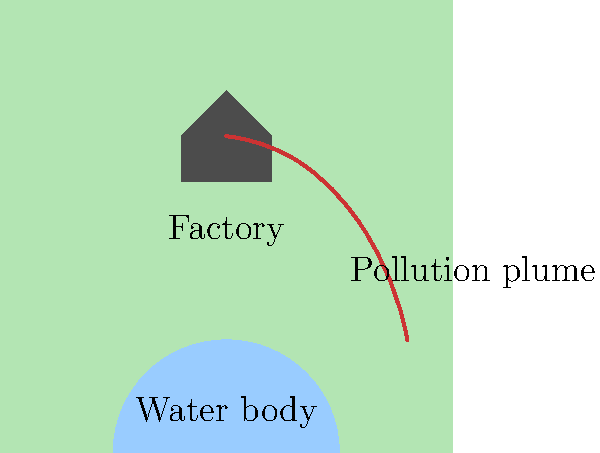In the aerial image above, which feature would be most useful for a machine learning algorithm to identify and classify industrial pollution sources? To identify and classify industrial pollution sources in aerial imagery using machine learning, we need to consider the most distinctive and relevant features. Let's analyze the key elements in the image:

1. Factory structure: While important, the factory itself may vary in shape and size across different industries, making it less reliable as a sole identifier.

2. Land area: The surrounding land doesn't provide specific information about pollution sources.

3. Water body: Although water bodies can be affected by pollution, they are not direct indicators of pollution sources.

4. Pollution plume: This is the most distinctive feature for identifying industrial pollution sources. The plume:
   a) Originates from the factory
   b) Has a characteristic shape and color
   c) Extends over a significant area
   d) Contrasts with the surrounding environment

Machine learning algorithms can be trained to recognize the unique patterns, colors, and shapes of pollution plumes in aerial imagery. These plumes are often the most visible and consistent indicators of industrial pollution sources across different types of facilities.

For a small business owner seeking to hold corporate polluters accountable, focusing on the pollution plume as the key feature for machine learning classification would provide the most reliable and actionable results in identifying potential violators.
Answer: Pollution plume 